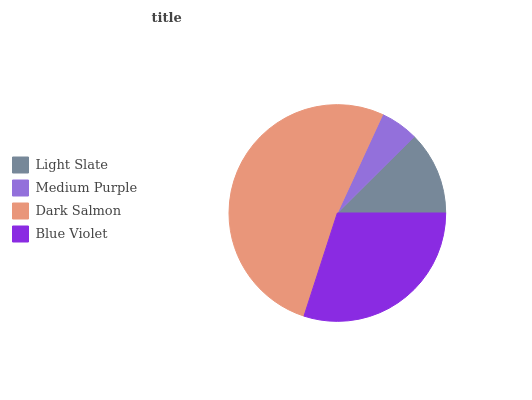Is Medium Purple the minimum?
Answer yes or no. Yes. Is Dark Salmon the maximum?
Answer yes or no. Yes. Is Dark Salmon the minimum?
Answer yes or no. No. Is Medium Purple the maximum?
Answer yes or no. No. Is Dark Salmon greater than Medium Purple?
Answer yes or no. Yes. Is Medium Purple less than Dark Salmon?
Answer yes or no. Yes. Is Medium Purple greater than Dark Salmon?
Answer yes or no. No. Is Dark Salmon less than Medium Purple?
Answer yes or no. No. Is Blue Violet the high median?
Answer yes or no. Yes. Is Light Slate the low median?
Answer yes or no. Yes. Is Dark Salmon the high median?
Answer yes or no. No. Is Medium Purple the low median?
Answer yes or no. No. 